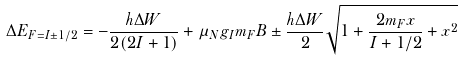<formula> <loc_0><loc_0><loc_500><loc_500>\Delta E _ { F = I \pm 1 / 2 } = - { \frac { h \Delta W } { 2 ( 2 I + 1 ) } } + \mu _ { N } g _ { I } m _ { F } B \pm { \frac { h \Delta W } { 2 } } { \sqrt { 1 + { \frac { 2 m _ { F } x } { I + 1 / 2 } } + x ^ { 2 } } }</formula> 